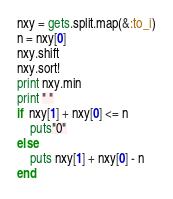<code> <loc_0><loc_0><loc_500><loc_500><_Ruby_>nxy = gets.split.map(&:to_i)
n = nxy[0]
nxy.shift
nxy.sort!
print nxy.min
print " "
if  nxy[1] + nxy[0] <= n
    puts"0"
else
    puts nxy[1] + nxy[0] - n
end</code> 